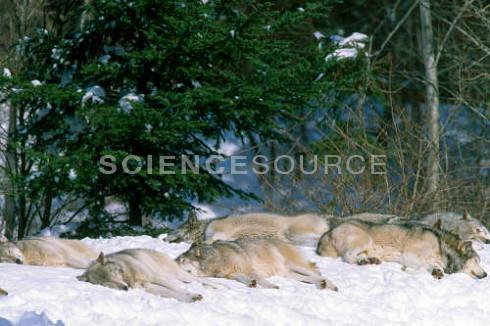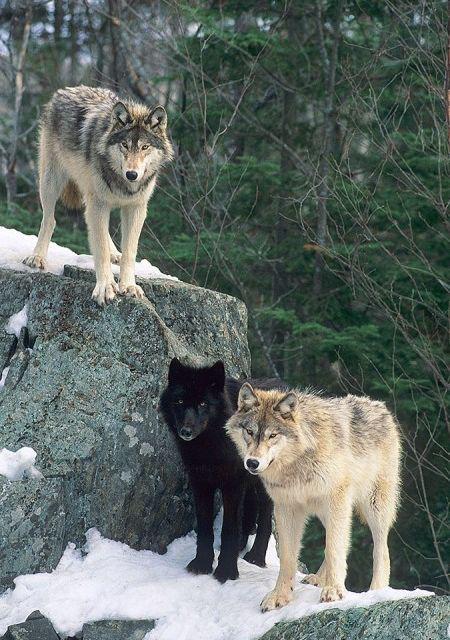The first image is the image on the left, the second image is the image on the right. Examine the images to the left and right. Is the description "The image on the left includes at least one adult wolf standing on all fours, and the image on the right includes three wolf pups." accurate? Answer yes or no. No. 